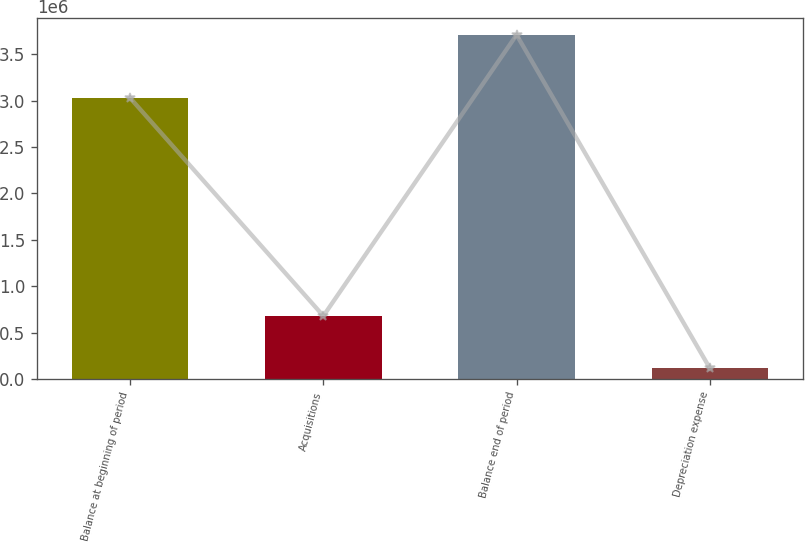Convert chart to OTSL. <chart><loc_0><loc_0><loc_500><loc_500><bar_chart><fcel>Balance at beginning of period<fcel>Acquisitions<fcel>Balance end of period<fcel>Depreciation expense<nl><fcel>3.0279e+06<fcel>679941<fcel>3.70784e+06<fcel>118238<nl></chart> 